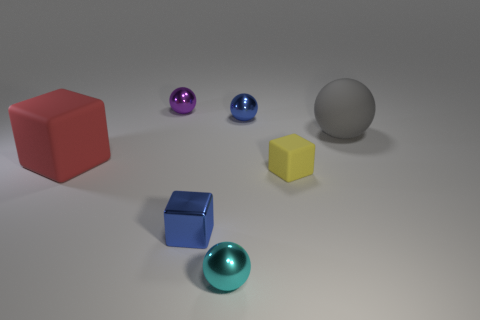Do the rubber sphere and the rubber thing on the left side of the yellow matte object have the same size?
Offer a terse response. Yes. Are there fewer big matte things that are to the right of the cyan sphere than matte blocks?
Your answer should be very brief. Yes. What number of things are the same color as the metal cube?
Give a very brief answer. 1. Are there fewer small matte blocks than tiny objects?
Your response must be concise. Yes. Is the material of the gray ball the same as the tiny blue sphere?
Your answer should be compact. No. What number of other objects are there of the same size as the gray rubber thing?
Your answer should be very brief. 1. The big rubber object on the left side of the large rubber object behind the large cube is what color?
Offer a terse response. Red. What number of other things are there of the same shape as the tiny purple object?
Your answer should be very brief. 3. Are there any red objects made of the same material as the cyan object?
Offer a very short reply. No. There is a cyan thing that is the same size as the blue metal ball; what is it made of?
Make the answer very short. Metal. 